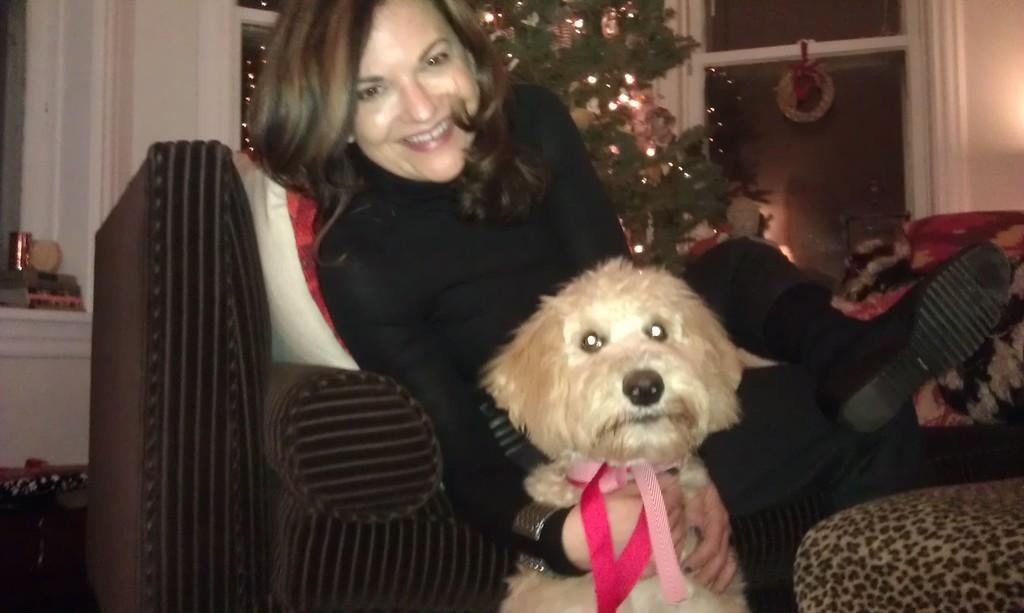Who is present in the image? There is a lady in the image. What type of animal is also present in the image? There is a dog in the image. What type of furniture can be seen in the image? There is a sofa in the image. What is the background of the image made of? There is a wall in the image. What other items can be seen in the image? There are objects and a plant in the image. What type of lighting is present in the image? There are lights in the image. What type of lace is being used to decorate the dog's collar in the image? There is no lace present in the image, nor is there any indication that the dog's collar is decorated. 